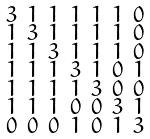Convert formula to latex. <formula><loc_0><loc_0><loc_500><loc_500>\begin{smallmatrix} 3 & 1 & 1 & 1 & 1 & 1 & 0 \\ 1 & 3 & 1 & 1 & 1 & 1 & 0 \\ 1 & 1 & 3 & 1 & 1 & 1 & 0 \\ 1 & 1 & 1 & 3 & 1 & 0 & 1 \\ 1 & 1 & 1 & 1 & 3 & 0 & 0 \\ 1 & 1 & 1 & 0 & 0 & 3 & 1 \\ 0 & 0 & 0 & 1 & 0 & 1 & 3 \end{smallmatrix}</formula> 